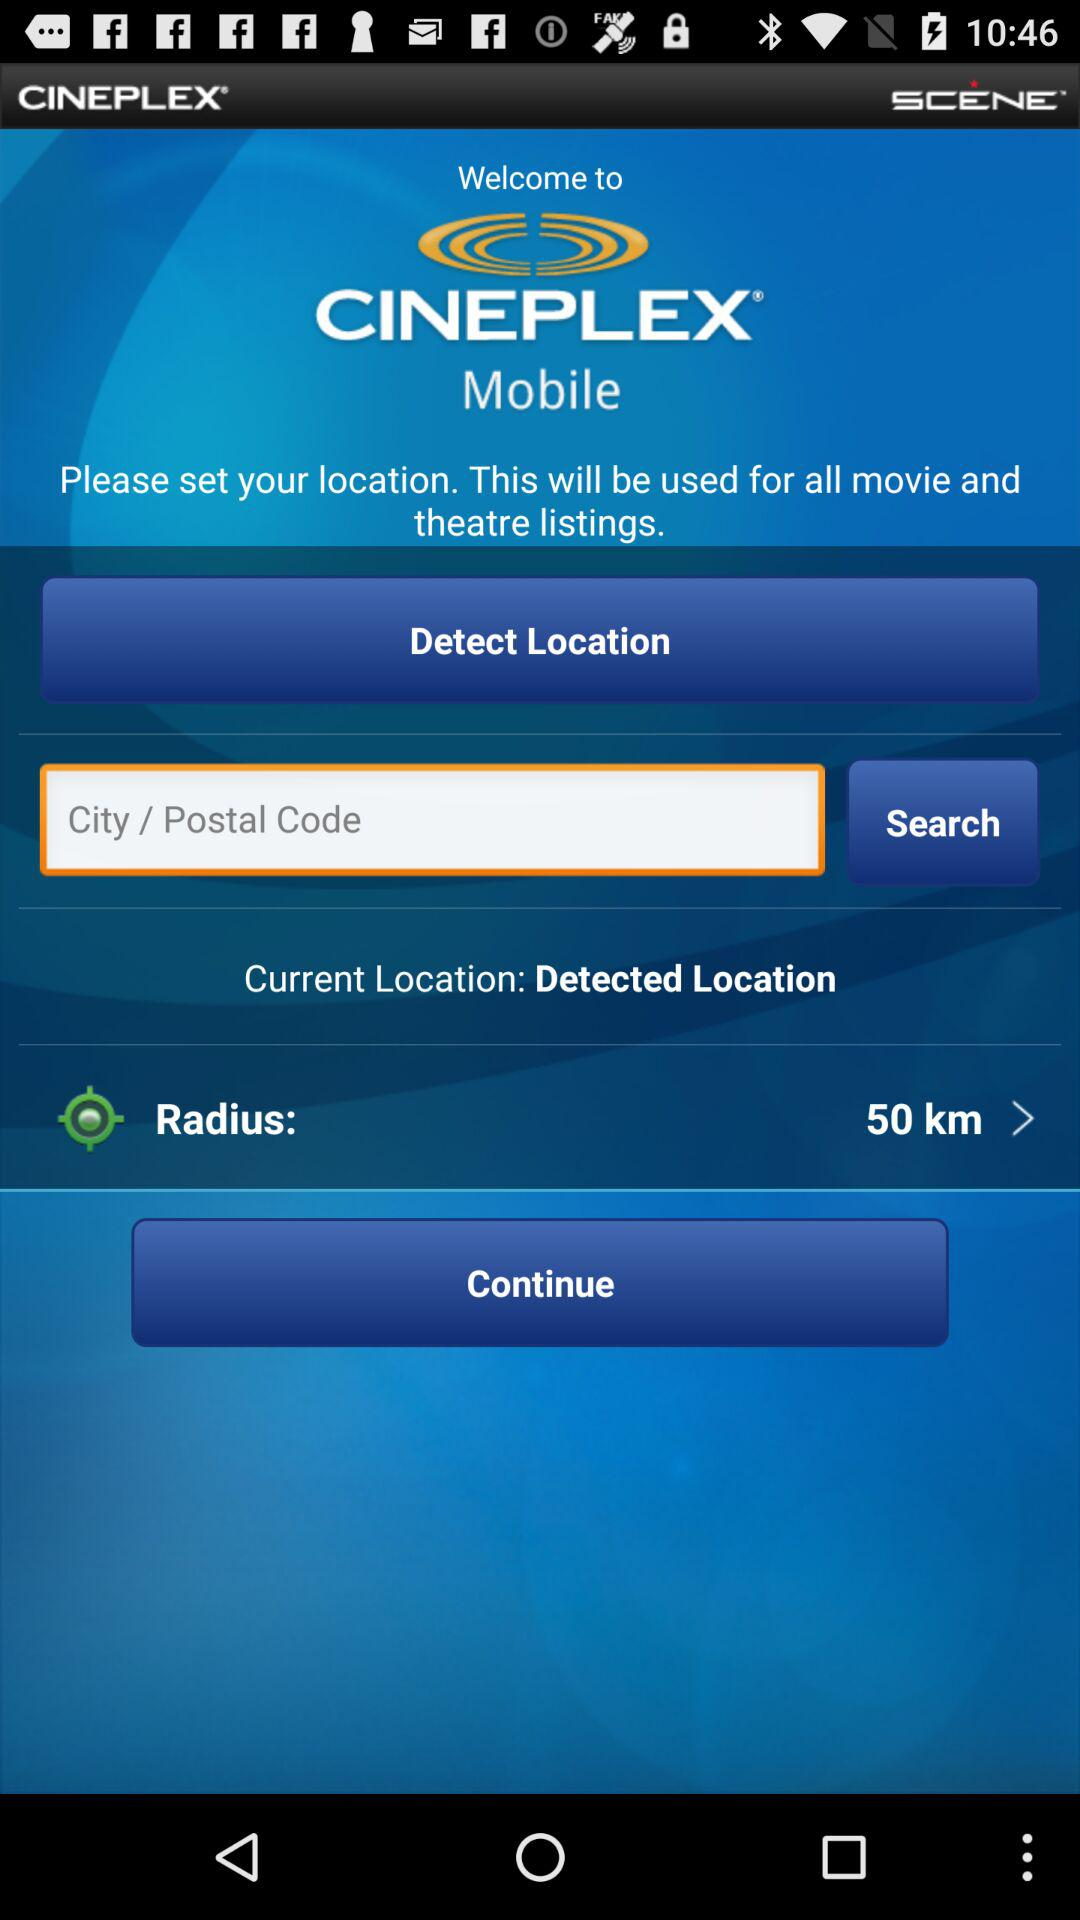What is the radius distance? The radius distance is 50 km. 